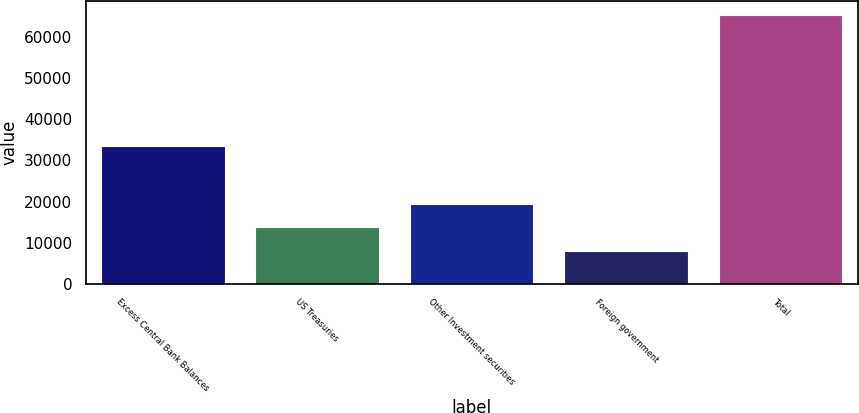Convert chart. <chart><loc_0><loc_0><loc_500><loc_500><bar_chart><fcel>Excess Central Bank Balances<fcel>US Treasuries<fcel>Other Investment securities<fcel>Foreign government<fcel>Total<nl><fcel>33584<fcel>13792.4<fcel>19520.8<fcel>8064<fcel>65348<nl></chart> 